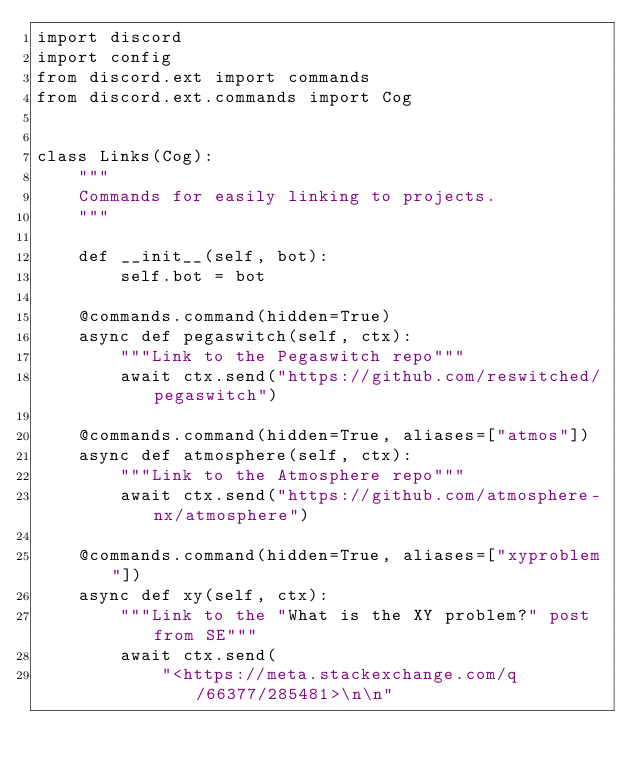<code> <loc_0><loc_0><loc_500><loc_500><_Python_>import discord
import config
from discord.ext import commands
from discord.ext.commands import Cog


class Links(Cog):
    """
    Commands for easily linking to projects.
    """

    def __init__(self, bot):
        self.bot = bot

    @commands.command(hidden=True)
    async def pegaswitch(self, ctx):
        """Link to the Pegaswitch repo"""
        await ctx.send("https://github.com/reswitched/pegaswitch")

    @commands.command(hidden=True, aliases=["atmos"])
    async def atmosphere(self, ctx):
        """Link to the Atmosphere repo"""
        await ctx.send("https://github.com/atmosphere-nx/atmosphere")

    @commands.command(hidden=True, aliases=["xyproblem"])
    async def xy(self, ctx):
        """Link to the "What is the XY problem?" post from SE"""
        await ctx.send(
            "<https://meta.stackexchange.com/q/66377/285481>\n\n"</code> 